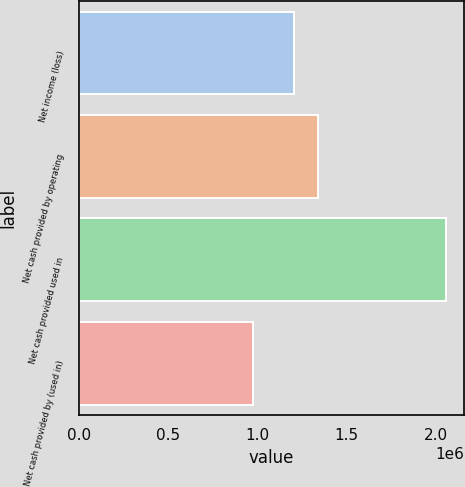Convert chart to OTSL. <chart><loc_0><loc_0><loc_500><loc_500><bar_chart><fcel>Net income (loss)<fcel>Net cash provided by operating<fcel>Net cash provided used in<fcel>Net cash provided by (used in)<nl><fcel>1.2056e+06<fcel>1.33971e+06<fcel>2.05551e+06<fcel>978116<nl></chart> 